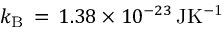Convert formula to latex. <formula><loc_0><loc_0><loc_500><loc_500>k _ { B } \, = \, 1 . 3 8 \times 1 0 ^ { - 2 3 } \, J K ^ { - 1 }</formula> 